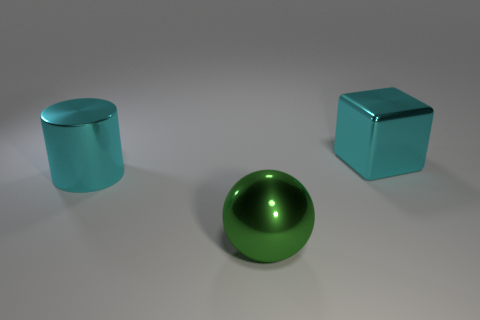Subtract all brown cylinders. Subtract all green cubes. How many cylinders are left? 1 Add 3 gray metallic cylinders. How many objects exist? 6 Subtract all cylinders. How many objects are left? 2 Subtract all red rubber cylinders. Subtract all shiny things. How many objects are left? 0 Add 2 big cyan shiny blocks. How many big cyan shiny blocks are left? 3 Add 3 metal cubes. How many metal cubes exist? 4 Subtract 0 red cylinders. How many objects are left? 3 